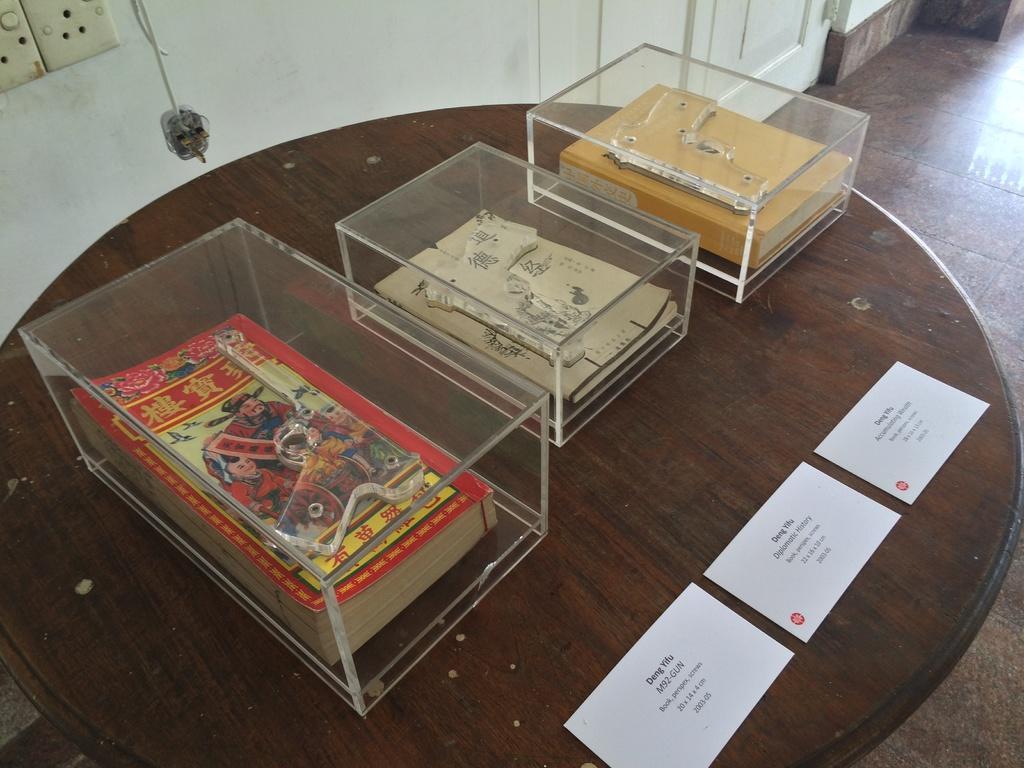Could you give a brief overview of what you see in this image? On this wooden table there are papers and glass boxes with books. Floor with tiles. Socket is on wall. 